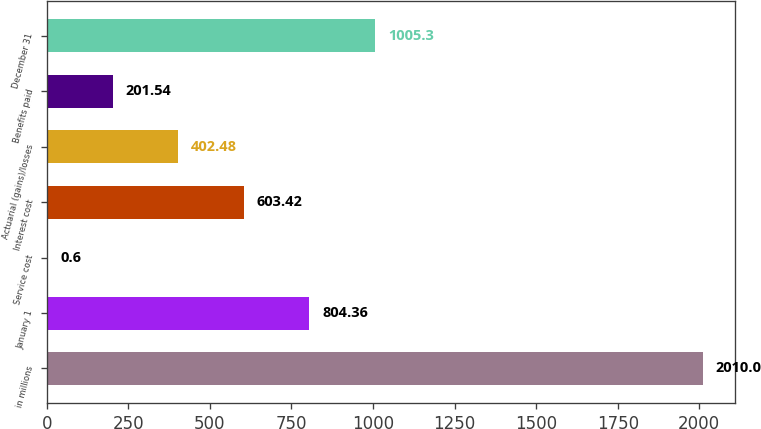Convert chart to OTSL. <chart><loc_0><loc_0><loc_500><loc_500><bar_chart><fcel>in millions<fcel>January 1<fcel>Service cost<fcel>Interest cost<fcel>Actuarial (gains)/losses<fcel>Benefits paid<fcel>December 31<nl><fcel>2010<fcel>804.36<fcel>0.6<fcel>603.42<fcel>402.48<fcel>201.54<fcel>1005.3<nl></chart> 